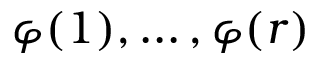Convert formula to latex. <formula><loc_0><loc_0><loc_500><loc_500>\varphi ( 1 ) , \dots , \varphi ( r )</formula> 